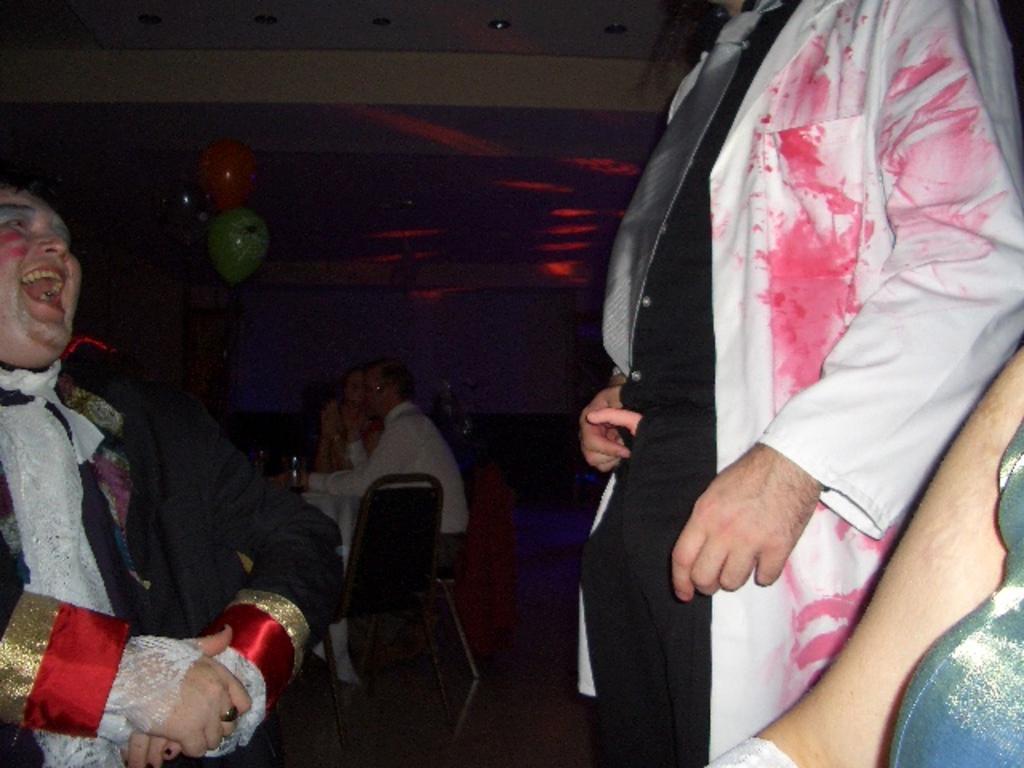Could you give a brief overview of what you see in this image? In this image, we can see people wearing costumes and some are sitting on the chairs and we can see a bottle on the table and there are balloons and a wall. At the top, there are lights. 